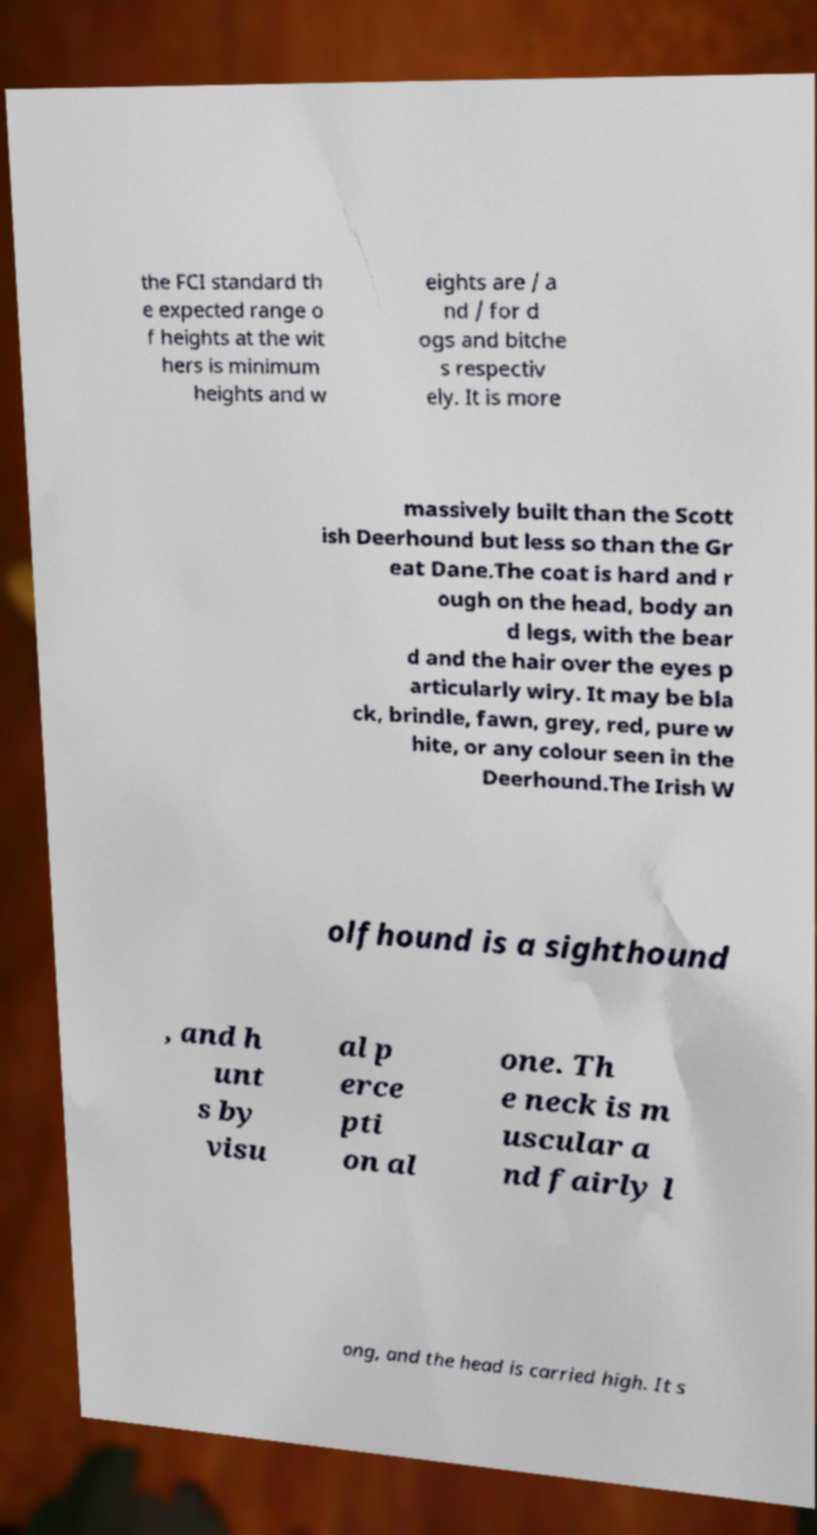Could you assist in decoding the text presented in this image and type it out clearly? the FCI standard th e expected range o f heights at the wit hers is minimum heights and w eights are / a nd / for d ogs and bitche s respectiv ely. It is more massively built than the Scott ish Deerhound but less so than the Gr eat Dane.The coat is hard and r ough on the head, body an d legs, with the bear d and the hair over the eyes p articularly wiry. It may be bla ck, brindle, fawn, grey, red, pure w hite, or any colour seen in the Deerhound.The Irish W olfhound is a sighthound , and h unt s by visu al p erce pti on al one. Th e neck is m uscular a nd fairly l ong, and the head is carried high. It s 